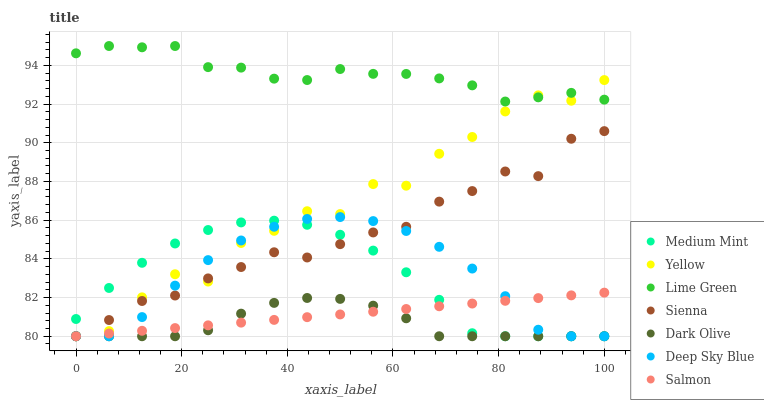Does Dark Olive have the minimum area under the curve?
Answer yes or no. Yes. Does Lime Green have the maximum area under the curve?
Answer yes or no. Yes. Does Salmon have the minimum area under the curve?
Answer yes or no. No. Does Salmon have the maximum area under the curve?
Answer yes or no. No. Is Salmon the smoothest?
Answer yes or no. Yes. Is Yellow the roughest?
Answer yes or no. Yes. Is Dark Olive the smoothest?
Answer yes or no. No. Is Dark Olive the roughest?
Answer yes or no. No. Does Medium Mint have the lowest value?
Answer yes or no. Yes. Does Lime Green have the lowest value?
Answer yes or no. No. Does Lime Green have the highest value?
Answer yes or no. Yes. Does Salmon have the highest value?
Answer yes or no. No. Is Medium Mint less than Lime Green?
Answer yes or no. Yes. Is Lime Green greater than Sienna?
Answer yes or no. Yes. Does Yellow intersect Dark Olive?
Answer yes or no. Yes. Is Yellow less than Dark Olive?
Answer yes or no. No. Is Yellow greater than Dark Olive?
Answer yes or no. No. Does Medium Mint intersect Lime Green?
Answer yes or no. No. 